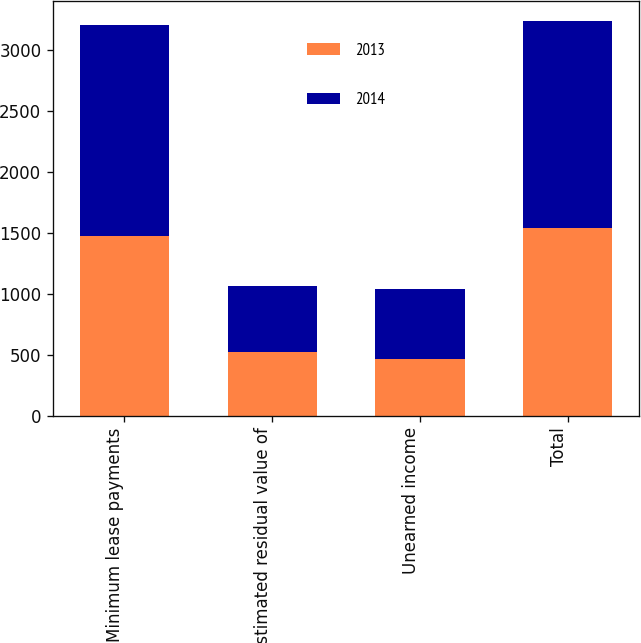Convert chart. <chart><loc_0><loc_0><loc_500><loc_500><stacked_bar_chart><ecel><fcel>Minimum lease payments<fcel>Estimated residual value of<fcel>Unearned income<fcel>Total<nl><fcel>2013<fcel>1475<fcel>521<fcel>461<fcel>1535<nl><fcel>2014<fcel>1731<fcel>543<fcel>575<fcel>1699<nl></chart> 